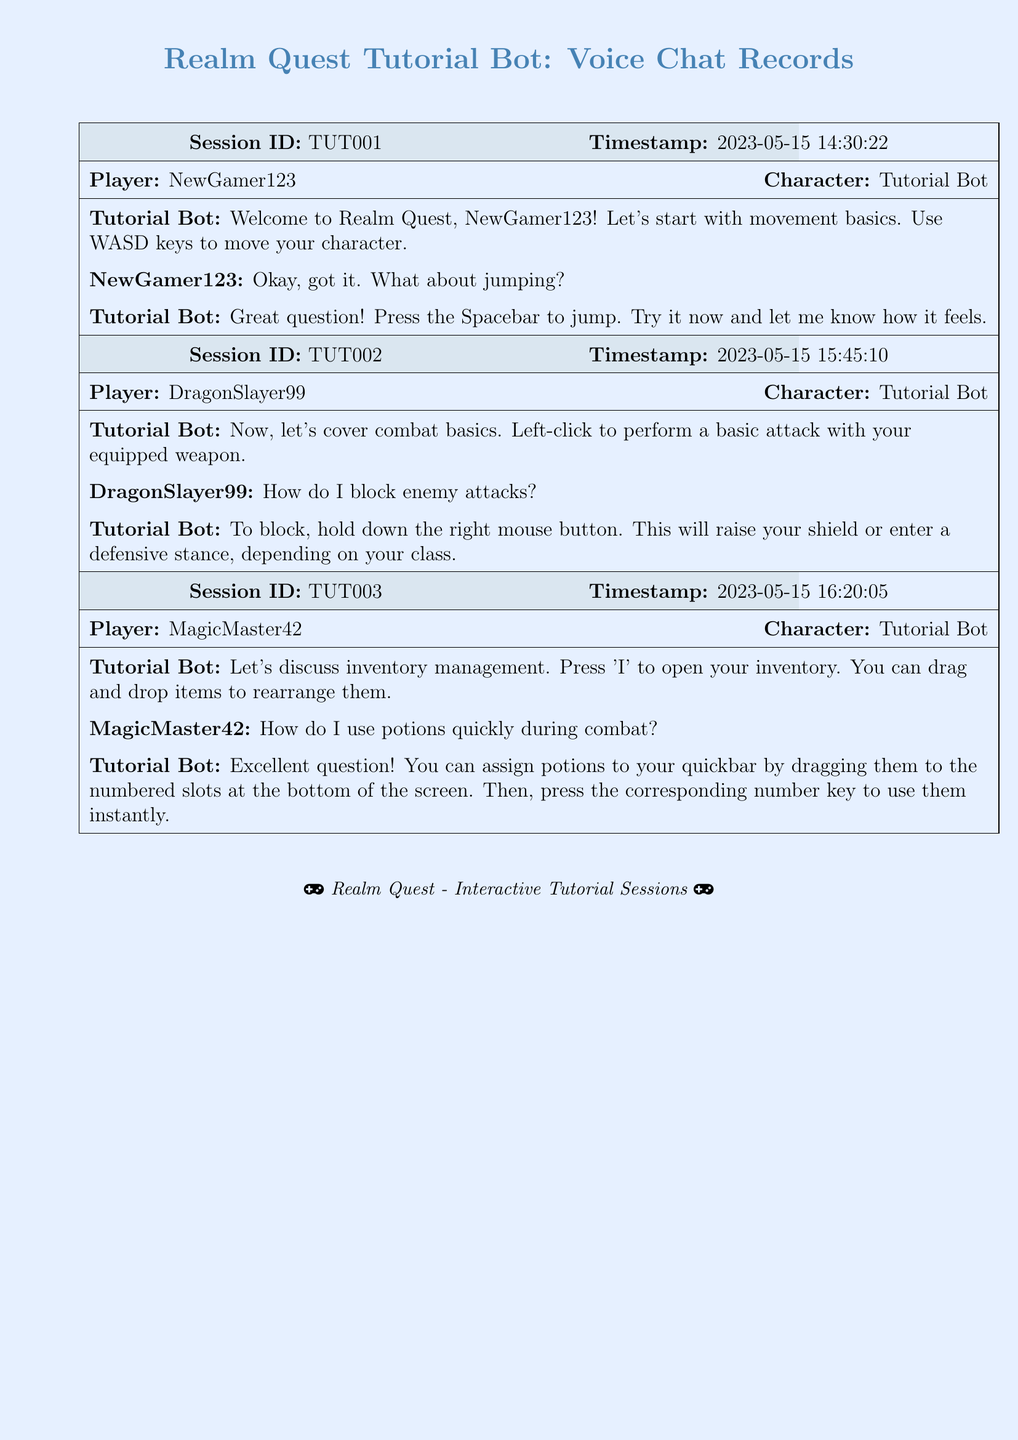What is the session ID of the first tutorial? The session ID is displayed in the header of the first tutorial, which is TUT001.
Answer: TUT001 Who was the first player to interact with the Tutorial Bot? The first player's name appears in the dialogue of the first session, NewGamer123 is the one who interacted first.
Answer: NewGamer123 What key is used to open the inventory? The instruction mentions pressing 'I' to open the inventory, which indicates the specific key to be used.
Answer: I What is the date and time of the second tutorial session? The date and time are written in the header of the second session, which is 2023-05-15 15:45:10.
Answer: 2023-05-15 15:45:10 How do you perform a basic attack according to the Tutorial Bot? Based on the Tutorial Bot's instruction, a basic attack is performed by left-clicking with the mouse.
Answer: Left-click What should you hold to block enemy attacks? The Tutorial Bot's advice indicates that holding down the right mouse button allows for blocking enemy attacks.
Answer: Right mouse button How can you use potions quickly during combat? The Tutorial Bot explains that potions can be assigned to a quickbar by dragging them to slots, allowing for instant use with number keys.
Answer: Dragging to quickbar How many players are involved in the voice chat sessions based on the document? By reviewing the player names across all sessions, there are three distinct players: NewGamer123, DragonSlayer99, and MagicMaster42.
Answer: Three Which player asked about jumping? The question about jumping was posed by the first player in the first session, NewGamer123.
Answer: NewGamer123 What is the main color theme used in the document? The document's color scheme is primarily represented with the color defined as gamebg (light blue) for the background.
Answer: Light blue 